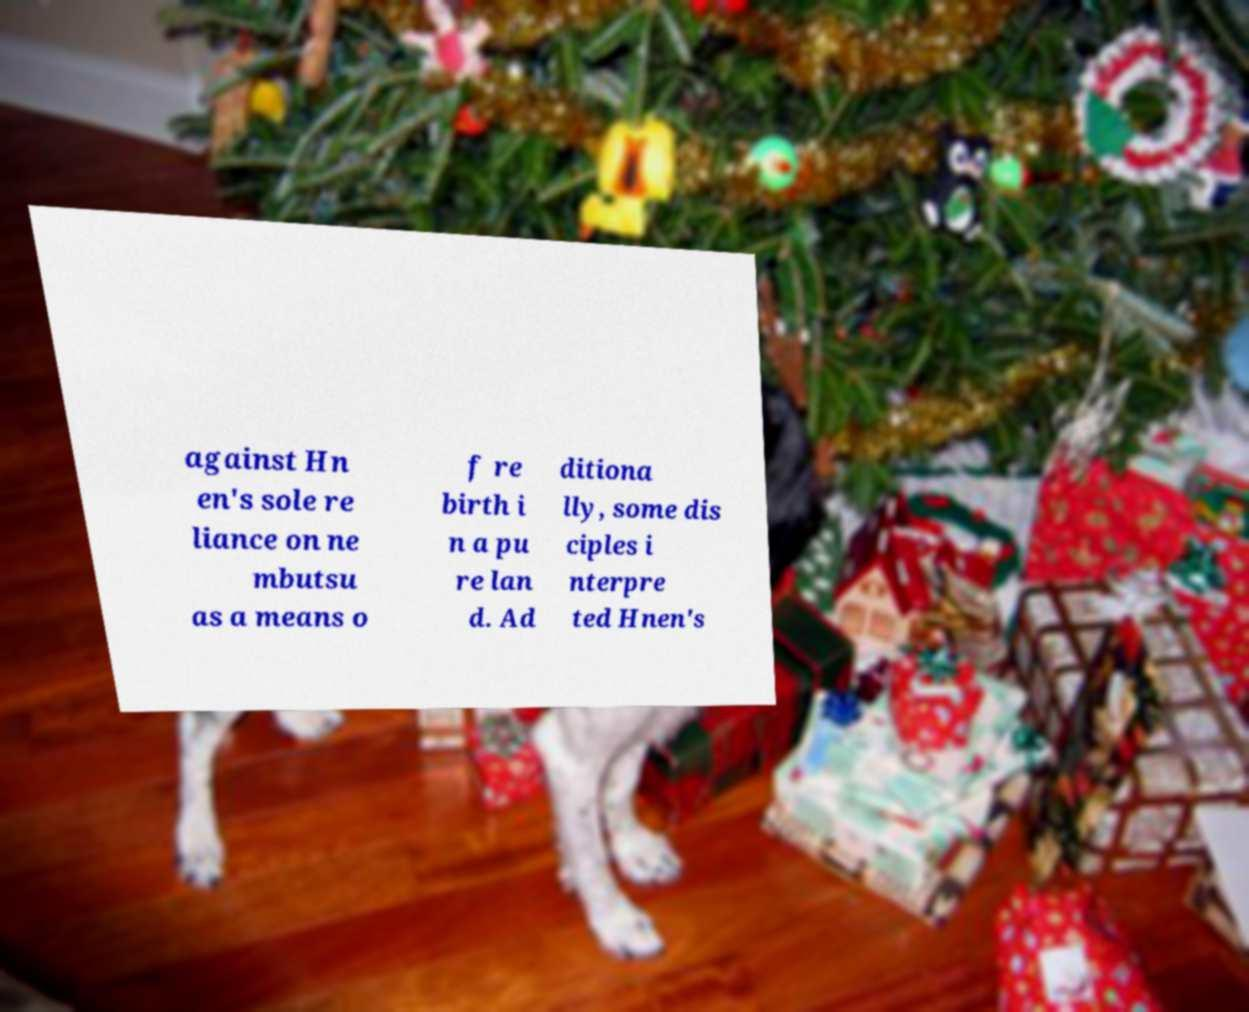Can you accurately transcribe the text from the provided image for me? against Hn en's sole re liance on ne mbutsu as a means o f re birth i n a pu re lan d. Ad ditiona lly, some dis ciples i nterpre ted Hnen's 